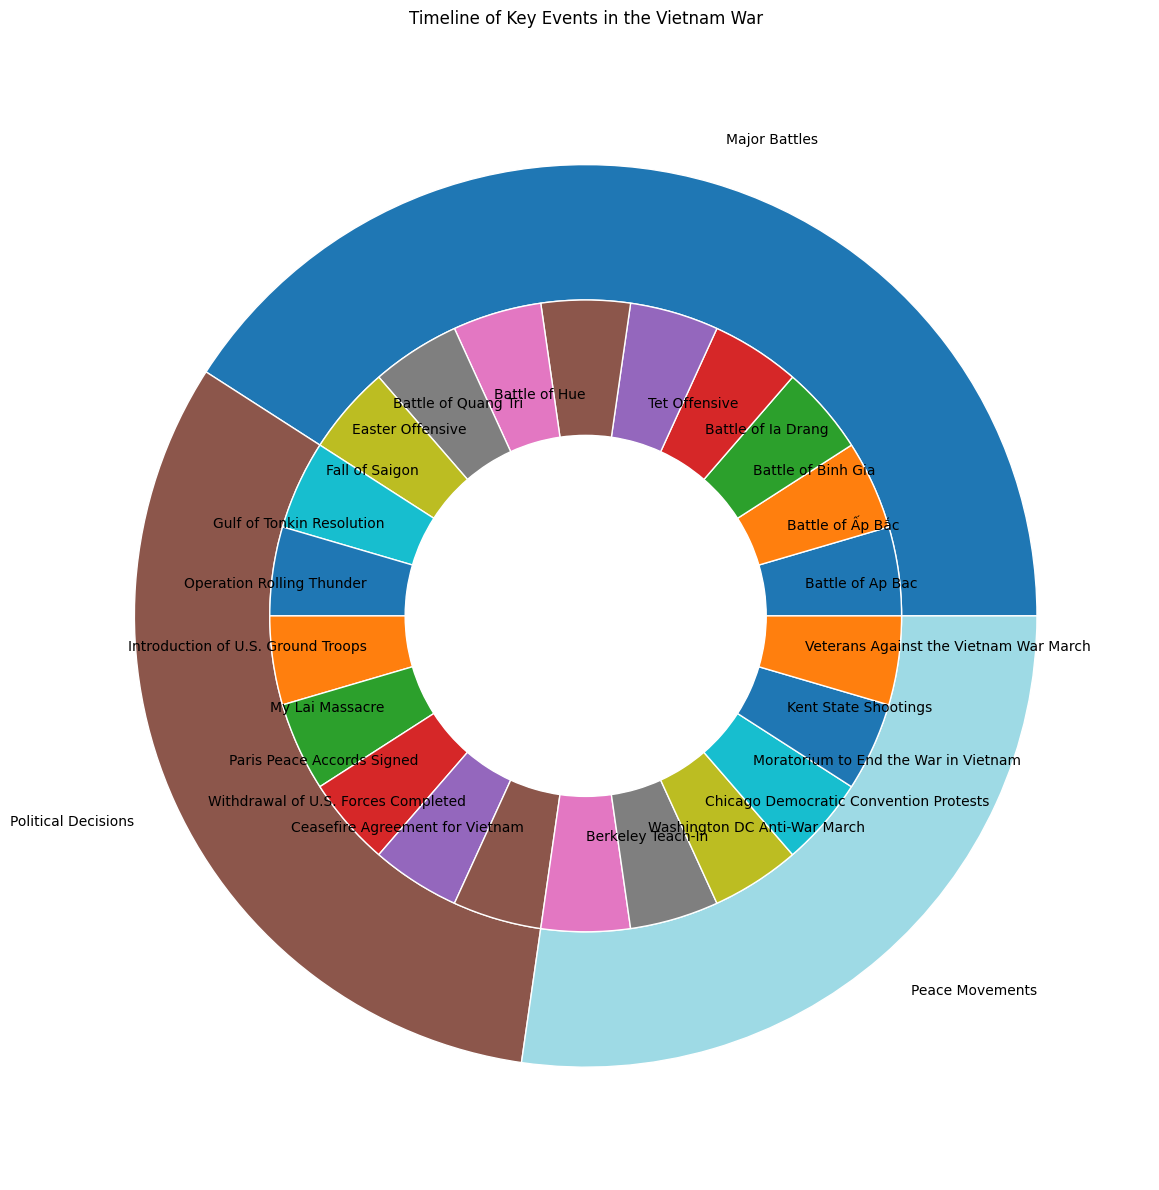What's the largest subcategory in "Major Battles"? The "Major Battles" category has three subcategories: "Early Engagements", "Significant Offensives", and "Endgame". By counting the number of events in each subcategory, we see that "Endgame" contains 3 events, which is more than the other subcategories.
Answer: Endgame Which category has the fewest events? The figure shows three main categories: "Major Battles", "Political Decisions", and "Peace Movements". We count the events in each category and find that "Peace Movements" has 6 events, which is fewer than both "Major Battles" and "Political Decisions".
Answer: Peace Movements How does the number of events in "Early Protests" compare with those in "Early Engagements"? "Early Protests" under "Peace Movements" and "Early Engagements" under "Major Battles" each have 3 events. Therefore, the two subcategories have an equal number of events.
Answer: Equal Which subcategory in "Political Decisions" has the most events? The subcategories under "Political Decisions" are "U.S. Involvement" (2 events), "Escalation" (2 events), and "De-escalation" (3 events). Thus, "De-escalation" has the most events.
Answer: De-escalation How many events occurred in "1968"? First, identify the events that occurred in "1968". They include "Tet Offensive", "Battle of Hue", "My Lai Massacre", and "Chicago Democratic Convention Protests", totaling 4 events.
Answer: 4 Which category has more subcategories: "Major Battles" or "Peace Movements"? "Major Battles" has three subcategories ("Early Engagements", "Significant Offensives", and "Endgame"), and "Peace Movements" has three subcategories ("Early Protests", "Major Demonstrations", and "Endgame"). Therefore, they both have the same number of subcategories.
Answer: Equal What's the shortest subcategory name in "Major Battles"? The subcategories in "Major Battles" are "Early Engagements", "Significant Offensives", and "Endgame". "Endgame" is the shortest in terms of characters.
Answer: Endgame What are the colors representing "Political Decisions" and "Peace Movements"? Based on the color coding in the pie chart, we see that "Political Decisions" is colored with one segment and "Peace Movements" with another. The colors represent different categories visually.
Answer: Different segments 